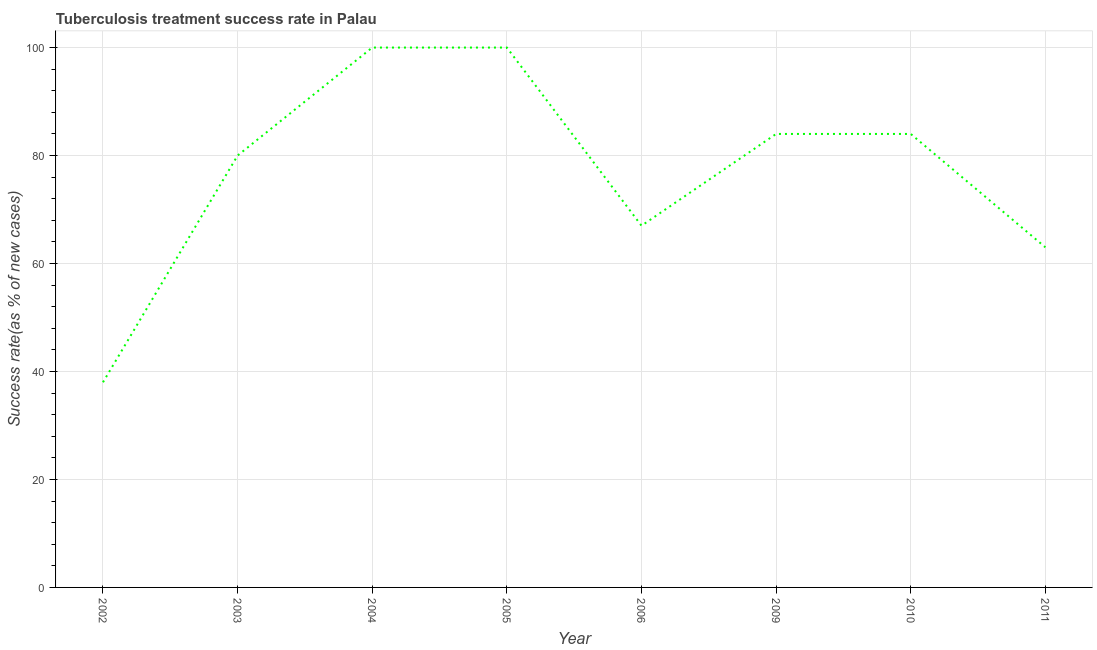What is the tuberculosis treatment success rate in 2010?
Make the answer very short. 84. Across all years, what is the maximum tuberculosis treatment success rate?
Offer a terse response. 100. Across all years, what is the minimum tuberculosis treatment success rate?
Ensure brevity in your answer.  38. In which year was the tuberculosis treatment success rate minimum?
Offer a terse response. 2002. What is the sum of the tuberculosis treatment success rate?
Offer a very short reply. 616. What is the difference between the tuberculosis treatment success rate in 2003 and 2010?
Ensure brevity in your answer.  -4. Do a majority of the years between 2010 and 2005 (inclusive) have tuberculosis treatment success rate greater than 84 %?
Give a very brief answer. Yes. What is the ratio of the tuberculosis treatment success rate in 2004 to that in 2009?
Give a very brief answer. 1.19. Is the sum of the tuberculosis treatment success rate in 2002 and 2010 greater than the maximum tuberculosis treatment success rate across all years?
Ensure brevity in your answer.  Yes. What is the difference between the highest and the lowest tuberculosis treatment success rate?
Keep it short and to the point. 62. How many lines are there?
Give a very brief answer. 1. How many years are there in the graph?
Make the answer very short. 8. What is the difference between two consecutive major ticks on the Y-axis?
Your answer should be very brief. 20. What is the title of the graph?
Provide a succinct answer. Tuberculosis treatment success rate in Palau. What is the label or title of the X-axis?
Make the answer very short. Year. What is the label or title of the Y-axis?
Provide a succinct answer. Success rate(as % of new cases). What is the Success rate(as % of new cases) of 2002?
Ensure brevity in your answer.  38. What is the Success rate(as % of new cases) in 2003?
Your answer should be compact. 80. What is the Success rate(as % of new cases) in 2004?
Your answer should be very brief. 100. What is the difference between the Success rate(as % of new cases) in 2002 and 2003?
Keep it short and to the point. -42. What is the difference between the Success rate(as % of new cases) in 2002 and 2004?
Make the answer very short. -62. What is the difference between the Success rate(as % of new cases) in 2002 and 2005?
Provide a succinct answer. -62. What is the difference between the Success rate(as % of new cases) in 2002 and 2009?
Give a very brief answer. -46. What is the difference between the Success rate(as % of new cases) in 2002 and 2010?
Your response must be concise. -46. What is the difference between the Success rate(as % of new cases) in 2003 and 2004?
Your answer should be compact. -20. What is the difference between the Success rate(as % of new cases) in 2003 and 2005?
Your answer should be compact. -20. What is the difference between the Success rate(as % of new cases) in 2003 and 2006?
Your answer should be very brief. 13. What is the difference between the Success rate(as % of new cases) in 2003 and 2009?
Offer a terse response. -4. What is the difference between the Success rate(as % of new cases) in 2003 and 2011?
Your answer should be very brief. 17. What is the difference between the Success rate(as % of new cases) in 2004 and 2005?
Keep it short and to the point. 0. What is the difference between the Success rate(as % of new cases) in 2004 and 2006?
Provide a succinct answer. 33. What is the difference between the Success rate(as % of new cases) in 2004 and 2010?
Your response must be concise. 16. What is the difference between the Success rate(as % of new cases) in 2005 and 2006?
Offer a very short reply. 33. What is the difference between the Success rate(as % of new cases) in 2005 and 2009?
Your response must be concise. 16. What is the difference between the Success rate(as % of new cases) in 2005 and 2010?
Provide a short and direct response. 16. What is the difference between the Success rate(as % of new cases) in 2005 and 2011?
Offer a terse response. 37. What is the difference between the Success rate(as % of new cases) in 2006 and 2009?
Your response must be concise. -17. What is the difference between the Success rate(as % of new cases) in 2006 and 2010?
Offer a terse response. -17. What is the difference between the Success rate(as % of new cases) in 2009 and 2010?
Provide a short and direct response. 0. What is the difference between the Success rate(as % of new cases) in 2009 and 2011?
Provide a short and direct response. 21. What is the difference between the Success rate(as % of new cases) in 2010 and 2011?
Give a very brief answer. 21. What is the ratio of the Success rate(as % of new cases) in 2002 to that in 2003?
Ensure brevity in your answer.  0.47. What is the ratio of the Success rate(as % of new cases) in 2002 to that in 2004?
Keep it short and to the point. 0.38. What is the ratio of the Success rate(as % of new cases) in 2002 to that in 2005?
Your answer should be very brief. 0.38. What is the ratio of the Success rate(as % of new cases) in 2002 to that in 2006?
Keep it short and to the point. 0.57. What is the ratio of the Success rate(as % of new cases) in 2002 to that in 2009?
Make the answer very short. 0.45. What is the ratio of the Success rate(as % of new cases) in 2002 to that in 2010?
Provide a short and direct response. 0.45. What is the ratio of the Success rate(as % of new cases) in 2002 to that in 2011?
Give a very brief answer. 0.6. What is the ratio of the Success rate(as % of new cases) in 2003 to that in 2004?
Keep it short and to the point. 0.8. What is the ratio of the Success rate(as % of new cases) in 2003 to that in 2006?
Give a very brief answer. 1.19. What is the ratio of the Success rate(as % of new cases) in 2003 to that in 2010?
Offer a very short reply. 0.95. What is the ratio of the Success rate(as % of new cases) in 2003 to that in 2011?
Your response must be concise. 1.27. What is the ratio of the Success rate(as % of new cases) in 2004 to that in 2006?
Provide a short and direct response. 1.49. What is the ratio of the Success rate(as % of new cases) in 2004 to that in 2009?
Offer a terse response. 1.19. What is the ratio of the Success rate(as % of new cases) in 2004 to that in 2010?
Your answer should be compact. 1.19. What is the ratio of the Success rate(as % of new cases) in 2004 to that in 2011?
Provide a short and direct response. 1.59. What is the ratio of the Success rate(as % of new cases) in 2005 to that in 2006?
Provide a short and direct response. 1.49. What is the ratio of the Success rate(as % of new cases) in 2005 to that in 2009?
Keep it short and to the point. 1.19. What is the ratio of the Success rate(as % of new cases) in 2005 to that in 2010?
Give a very brief answer. 1.19. What is the ratio of the Success rate(as % of new cases) in 2005 to that in 2011?
Keep it short and to the point. 1.59. What is the ratio of the Success rate(as % of new cases) in 2006 to that in 2009?
Offer a very short reply. 0.8. What is the ratio of the Success rate(as % of new cases) in 2006 to that in 2010?
Provide a short and direct response. 0.8. What is the ratio of the Success rate(as % of new cases) in 2006 to that in 2011?
Provide a short and direct response. 1.06. What is the ratio of the Success rate(as % of new cases) in 2009 to that in 2011?
Keep it short and to the point. 1.33. What is the ratio of the Success rate(as % of new cases) in 2010 to that in 2011?
Offer a terse response. 1.33. 